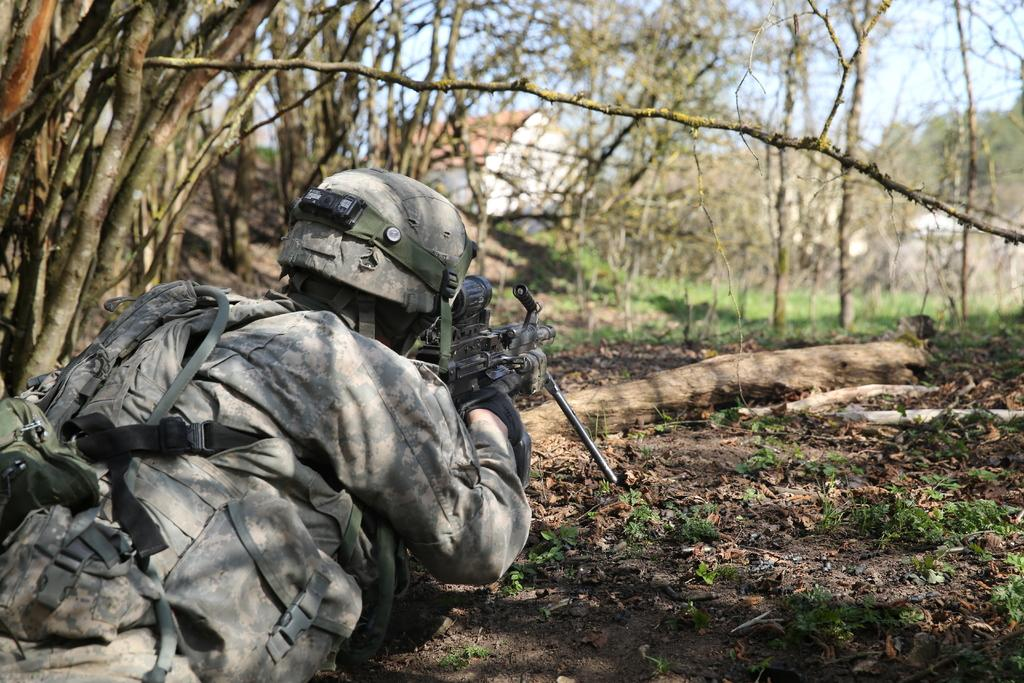What is the person in the image holding? The person in the image is holding a gun. What type of natural environment is depicted in the image? There are many trees, plants, and a grassy land in the image, indicating a natural environment. What can be seen in the sky in the image? The sky is visible in the image. What type of property does the queen own in the image? There is no queen or property mentioned in the image; it features a person holding a gun in a natural environment. 